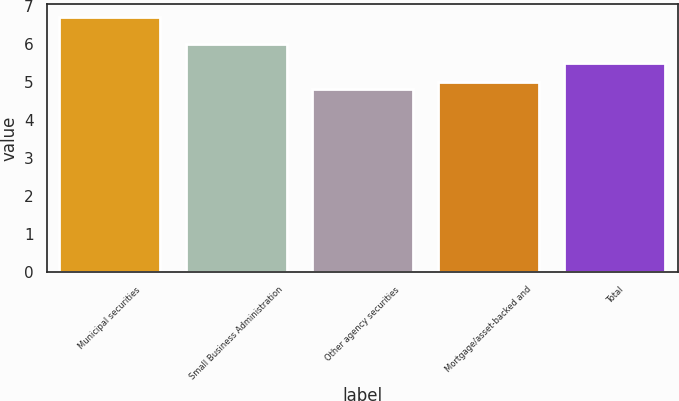Convert chart. <chart><loc_0><loc_0><loc_500><loc_500><bar_chart><fcel>Municipal securities<fcel>Small Business Administration<fcel>Other agency securities<fcel>Mortgage/asset-backed and<fcel>Total<nl><fcel>6.7<fcel>6<fcel>4.8<fcel>5<fcel>5.5<nl></chart> 